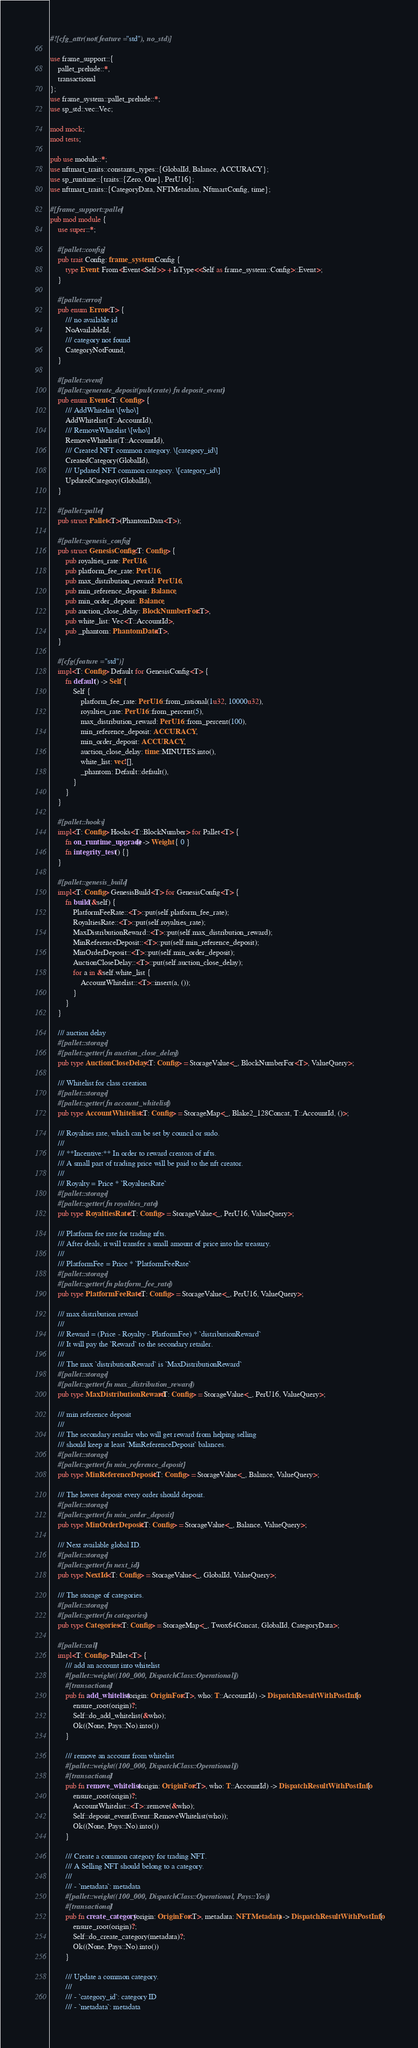<code> <loc_0><loc_0><loc_500><loc_500><_Rust_>#![cfg_attr(not(feature = "std"), no_std)]

use frame_support::{
	pallet_prelude::*,
	transactional
};
use frame_system::pallet_prelude::*;
use sp_std::vec::Vec;

mod mock;
mod tests;

pub use module::*;
use nftmart_traits::constants_types::{GlobalId, Balance, ACCURACY};
use sp_runtime::{traits::{Zero, One}, PerU16};
use nftmart_traits::{CategoryData, NFTMetadata, NftmartConfig, time};

#[frame_support::pallet]
pub mod module {
	use super::*;

	#[pallet::config]
	pub trait Config: frame_system::Config {
		type Event: From<Event<Self>> + IsType<<Self as frame_system::Config>::Event>;
	}

	#[pallet::error]
	pub enum Error<T> {
		/// no available id
		NoAvailableId,
		/// category not found
		CategoryNotFound,
	}

	#[pallet::event]
	#[pallet::generate_deposit(pub(crate) fn deposit_event)]
	pub enum Event<T: Config> {
		/// AddWhitelist \[who\]
		AddWhitelist(T::AccountId),
		/// RemoveWhitelist \[who\]
		RemoveWhitelist(T::AccountId),
		/// Created NFT common category. \[category_id\]
		CreatedCategory(GlobalId),
		/// Updated NFT common category. \[category_id\]
		UpdatedCategory(GlobalId),
	}

	#[pallet::pallet]
	pub struct Pallet<T>(PhantomData<T>);

	#[pallet::genesis_config]
	pub struct GenesisConfig<T: Config> {
		pub royalties_rate: PerU16,
		pub platform_fee_rate: PerU16,
		pub max_distribution_reward: PerU16,
		pub min_reference_deposit: Balance,
		pub min_order_deposit: Balance,
		pub auction_close_delay: BlockNumberFor<T>,
		pub white_list: Vec<T::AccountId>,
		pub _phantom: PhantomData<T>,
	}

	#[cfg(feature = "std")]
	impl<T: Config> Default for GenesisConfig<T> {
		fn default() -> Self {
			Self {
				platform_fee_rate: PerU16::from_rational(1u32, 10000u32),
				royalties_rate: PerU16::from_percent(5),
				max_distribution_reward: PerU16::from_percent(100),
				min_reference_deposit: ACCURACY,
				min_order_deposit: ACCURACY,
				auction_close_delay: time::MINUTES.into(),
				white_list: vec![],
				_phantom: Default::default(),
			}
		}
	}

	#[pallet::hooks]
	impl<T: Config> Hooks<T::BlockNumber> for Pallet<T> {
		fn on_runtime_upgrade() -> Weight { 0 }
		fn integrity_test () {}
	}

	#[pallet::genesis_build]
	impl<T: Config> GenesisBuild<T> for GenesisConfig<T> {
		fn build(&self) {
			PlatformFeeRate::<T>::put(self.platform_fee_rate);
			RoyaltiesRate::<T>::put(self.royalties_rate);
			MaxDistributionReward::<T>::put(self.max_distribution_reward);
			MinReferenceDeposit::<T>::put(self.min_reference_deposit);
			MinOrderDeposit::<T>::put(self.min_order_deposit);
			AuctionCloseDelay::<T>::put(self.auction_close_delay);
			for a in &self.white_list {
				AccountWhitelist::<T>::insert(a, ());
			}
		}
	}

	/// auction delay
	#[pallet::storage]
	#[pallet::getter(fn auction_close_delay)]
	pub type AuctionCloseDelay<T: Config> = StorageValue<_, BlockNumberFor<T>, ValueQuery>;

	/// Whitelist for class creation
	#[pallet::storage]
	#[pallet::getter(fn account_whitelist)]
	pub type AccountWhitelist<T: Config> = StorageMap<_, Blake2_128Concat, T::AccountId, ()>;

	/// Royalties rate, which can be set by council or sudo.
	///
	/// **Incentive:** In order to reward creators of nfts.
	/// A small part of trading price will be paid to the nft creator.
	///
	/// Royalty = Price * `RoyaltiesRate`
	#[pallet::storage]
	#[pallet::getter(fn royalties_rate)]
	pub type RoyaltiesRate<T: Config> = StorageValue<_, PerU16, ValueQuery>;

	/// Platform fee rate for trading nfts.
	/// After deals, it will transfer a small amount of price into the treasury.
	///
	/// PlatformFee = Price * `PlatformFeeRate`
	#[pallet::storage]
	#[pallet::getter(fn platform_fee_rate)]
	pub type PlatformFeeRate<T: Config> = StorageValue<_, PerU16, ValueQuery>;

	/// max distribution reward
	///
	/// Reward = (Price - Royalty - PlatformFee) * `distributionReward`
	/// It will pay the `Reward` to the secondary retailer.
	///
	/// The max `distributionReward` is `MaxDistributionReward`
	#[pallet::storage]
	#[pallet::getter(fn max_distribution_reward)]
	pub type MaxDistributionReward<T: Config> = StorageValue<_, PerU16, ValueQuery>;

	/// min reference deposit
	///
	/// The secondary retailer who will get reward from helping selling
	/// should keep at least `MinReferenceDeposit` balances.
	#[pallet::storage]
	#[pallet::getter(fn min_reference_deposit)]
	pub type MinReferenceDeposit<T: Config> = StorageValue<_, Balance, ValueQuery>;

	/// The lowest deposit every order should deposit.
	#[pallet::storage]
	#[pallet::getter(fn min_order_deposit)]
	pub type MinOrderDeposit<T: Config> = StorageValue<_, Balance, ValueQuery>;

	/// Next available global ID.
	#[pallet::storage]
	#[pallet::getter(fn next_id)]
	pub type NextId<T: Config> = StorageValue<_, GlobalId, ValueQuery>;

	/// The storage of categories.
	#[pallet::storage]
	#[pallet::getter(fn categories)]
	pub type Categories<T: Config> = StorageMap<_, Twox64Concat, GlobalId, CategoryData>;

	#[pallet::call]
	impl<T: Config> Pallet<T> {
		/// add an account into whitelist
		#[pallet::weight((100_000, DispatchClass::Operational))]
		#[transactional]
		pub fn add_whitelist(origin: OriginFor<T>, who: T::AccountId) -> DispatchResultWithPostInfo {
			ensure_root(origin)?;
			Self::do_add_whitelist(&who);
			Ok((None, Pays::No).into())
		}

		/// remove an account from whitelist
		#[pallet::weight((100_000, DispatchClass::Operational))]
		#[transactional]
		pub fn remove_whitelist(origin: OriginFor<T>, who: T::AccountId) -> DispatchResultWithPostInfo {
			ensure_root(origin)?;
			AccountWhitelist::<T>::remove(&who);
			Self::deposit_event(Event::RemoveWhitelist(who));
			Ok((None, Pays::No).into())
		}

		/// Create a common category for trading NFT.
		/// A Selling NFT should belong to a category.
		///
		/// - `metadata`: metadata
		#[pallet::weight((100_000, DispatchClass::Operational, Pays::Yes))]
		#[transactional]
		pub fn create_category(origin: OriginFor<T>, metadata: NFTMetadata) -> DispatchResultWithPostInfo {
			ensure_root(origin)?;
			Self::do_create_category(metadata)?;
			Ok((None, Pays::No).into())
		}

		/// Update a common category.
		///
		/// - `category_id`: category ID
		/// - `metadata`: metadata</code> 